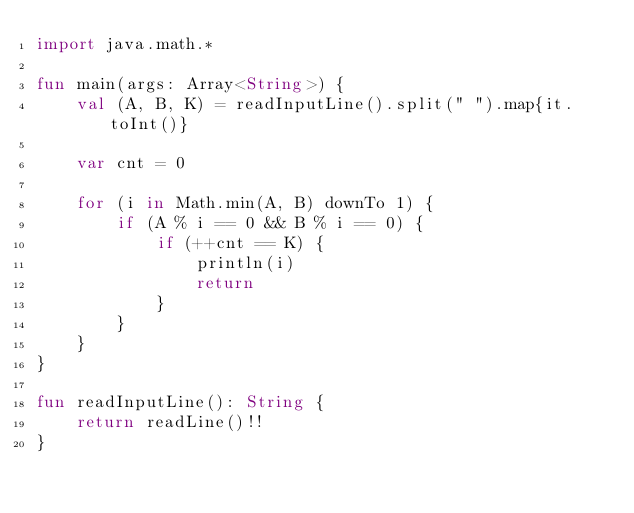Convert code to text. <code><loc_0><loc_0><loc_500><loc_500><_Kotlin_>import java.math.*

fun main(args: Array<String>) {
    val (A, B, K) = readInputLine().split(" ").map{it.toInt()}
    
    var cnt = 0
    
    for (i in Math.min(A, B) downTo 1) {
        if (A % i == 0 && B % i == 0) {
            if (++cnt == K) {
                println(i)
                return
            }
        }
    }
}

fun readInputLine(): String {
    return readLine()!!
}
</code> 